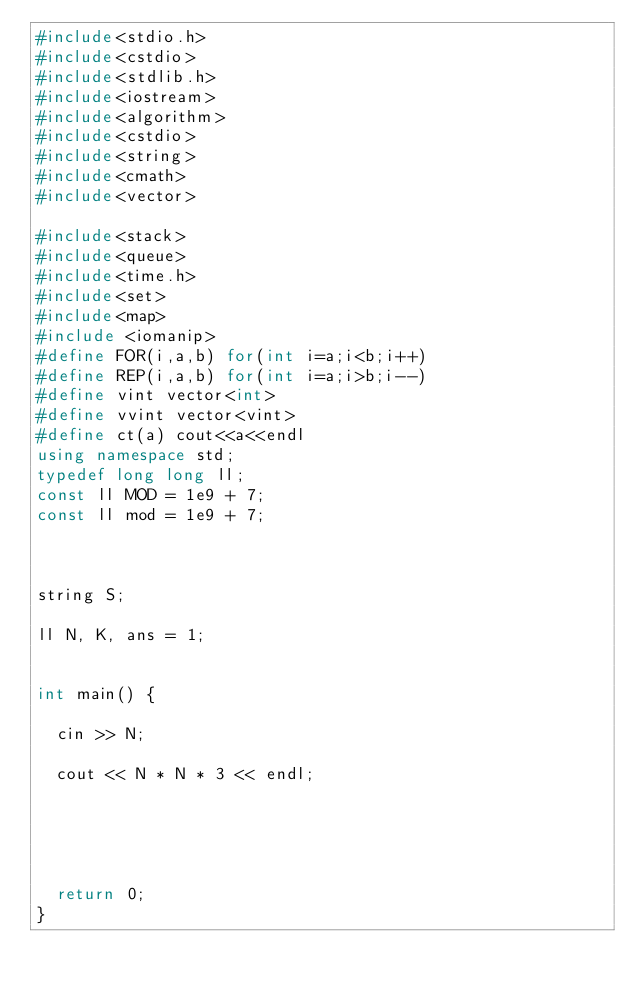<code> <loc_0><loc_0><loc_500><loc_500><_C++_>#include<stdio.h>
#include<cstdio>
#include<stdlib.h>
#include<iostream>
#include<algorithm>
#include<cstdio>
#include<string>
#include<cmath>
#include<vector>

#include<stack>
#include<queue>
#include<time.h>
#include<set>
#include<map>
#include <iomanip>
#define FOR(i,a,b) for(int i=a;i<b;i++)
#define REP(i,a,b) for(int i=a;i>b;i--)
#define vint vector<int> 
#define vvint vector<vint>
#define ct(a) cout<<a<<endl
using namespace std;
typedef long long ll;
const ll MOD = 1e9 + 7;
const ll mod = 1e9 + 7;



string S;

ll N, K, ans = 1;


int main() {

	cin >> N;
	
	cout << N * N * 3 << endl;





	return 0;
}
</code> 